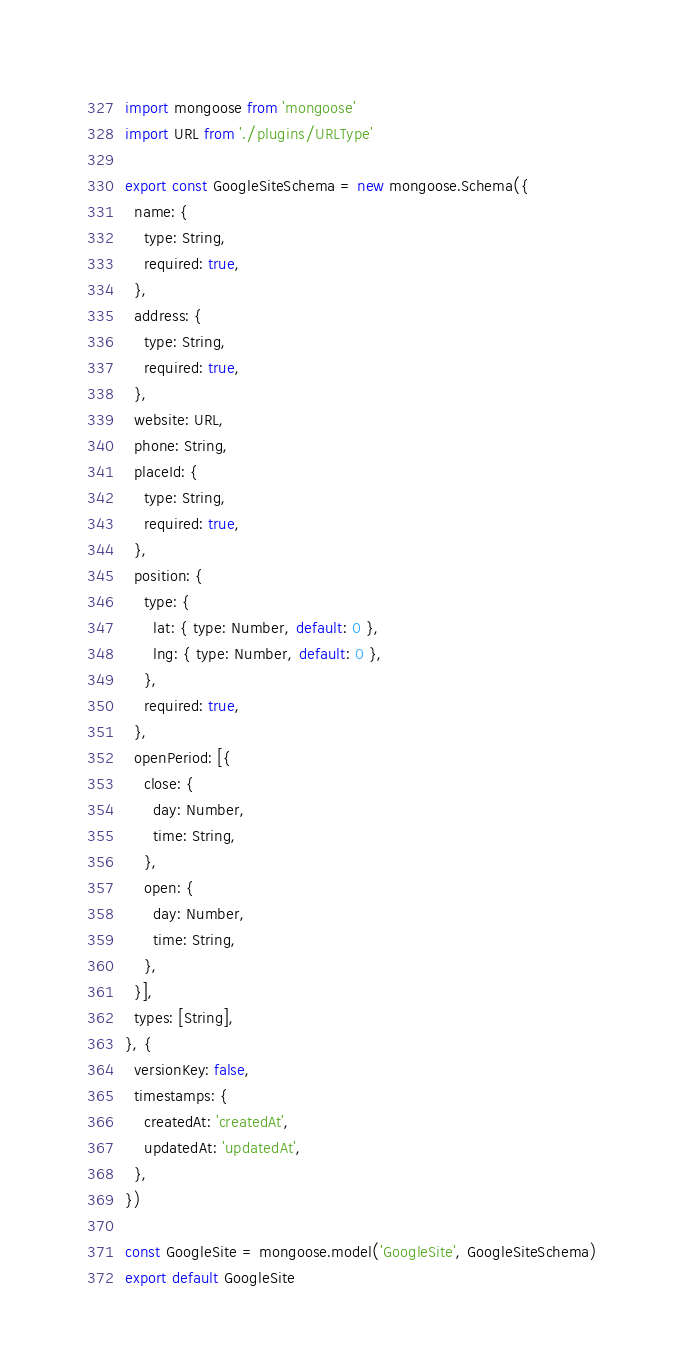Convert code to text. <code><loc_0><loc_0><loc_500><loc_500><_JavaScript_>import mongoose from 'mongoose'
import URL from './plugins/URLType'

export const GoogleSiteSchema = new mongoose.Schema({
  name: {
    type: String,
    required: true,
  },
  address: {
    type: String,
    required: true,
  },
  website: URL,
  phone: String,
  placeId: {
    type: String,
    required: true,
  },
  position: {
    type: {
      lat: { type: Number, default: 0 },
      lng: { type: Number, default: 0 },
    },
    required: true,
  },
  openPeriod: [{
    close: {
      day: Number,
      time: String,
    },
    open: {
      day: Number,
      time: String,
    },
  }],
  types: [String],
}, {
  versionKey: false,
  timestamps: {
    createdAt: 'createdAt',
    updatedAt: 'updatedAt',
  },
})

const GoogleSite = mongoose.model('GoogleSite', GoogleSiteSchema)
export default GoogleSite
</code> 